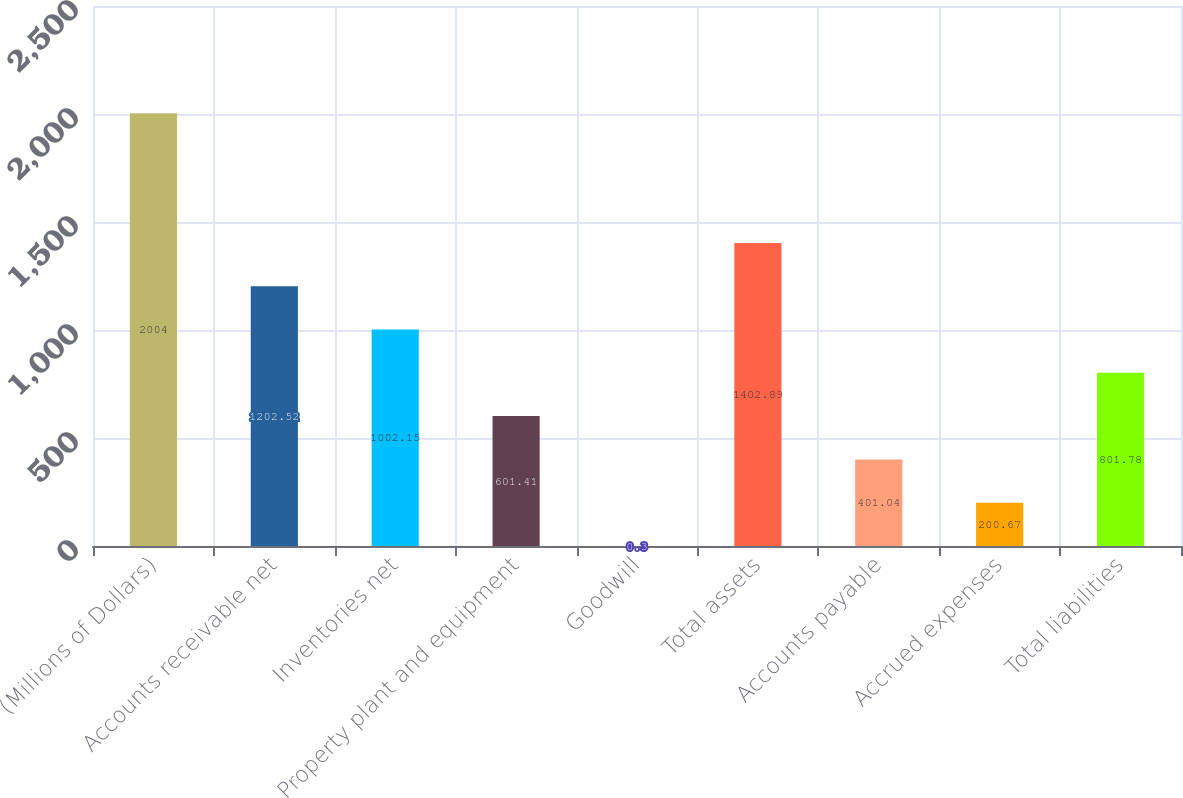<chart> <loc_0><loc_0><loc_500><loc_500><bar_chart><fcel>(Millions of Dollars)<fcel>Accounts receivable net<fcel>Inventories net<fcel>Property plant and equipment<fcel>Goodwill<fcel>Total assets<fcel>Accounts payable<fcel>Accrued expenses<fcel>Total liabilities<nl><fcel>2004<fcel>1202.52<fcel>1002.15<fcel>601.41<fcel>0.3<fcel>1402.89<fcel>401.04<fcel>200.67<fcel>801.78<nl></chart> 